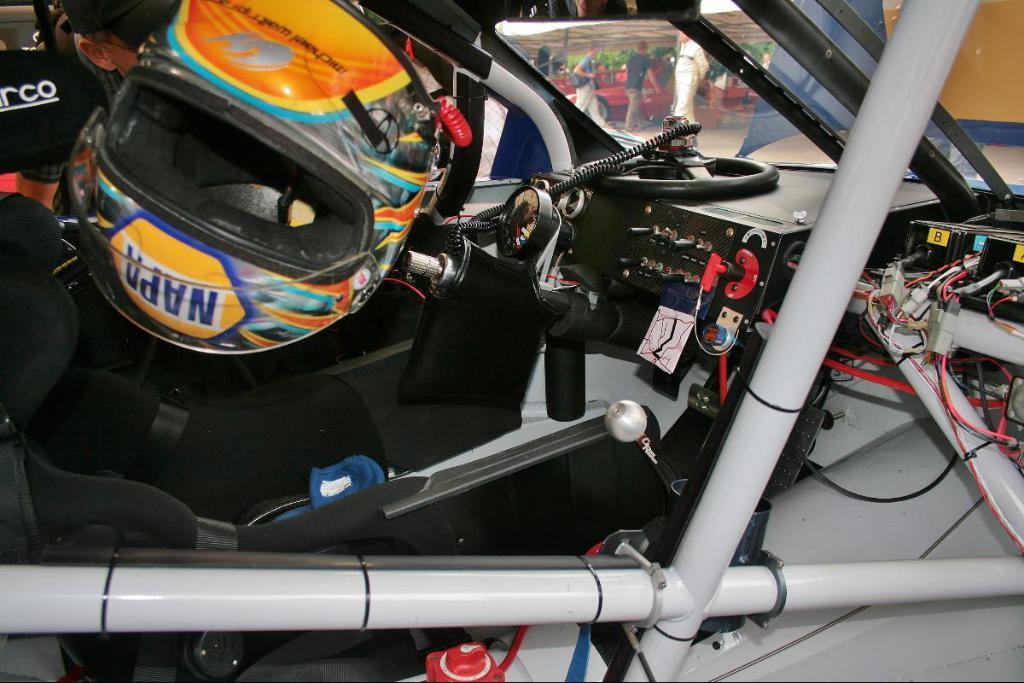Please provide a concise description of this image. In this picture, we can see a helmet in a car and in the car there is a gear lever, steering, cables and other things. Behind the vehicle, there are some people standing on the path. 